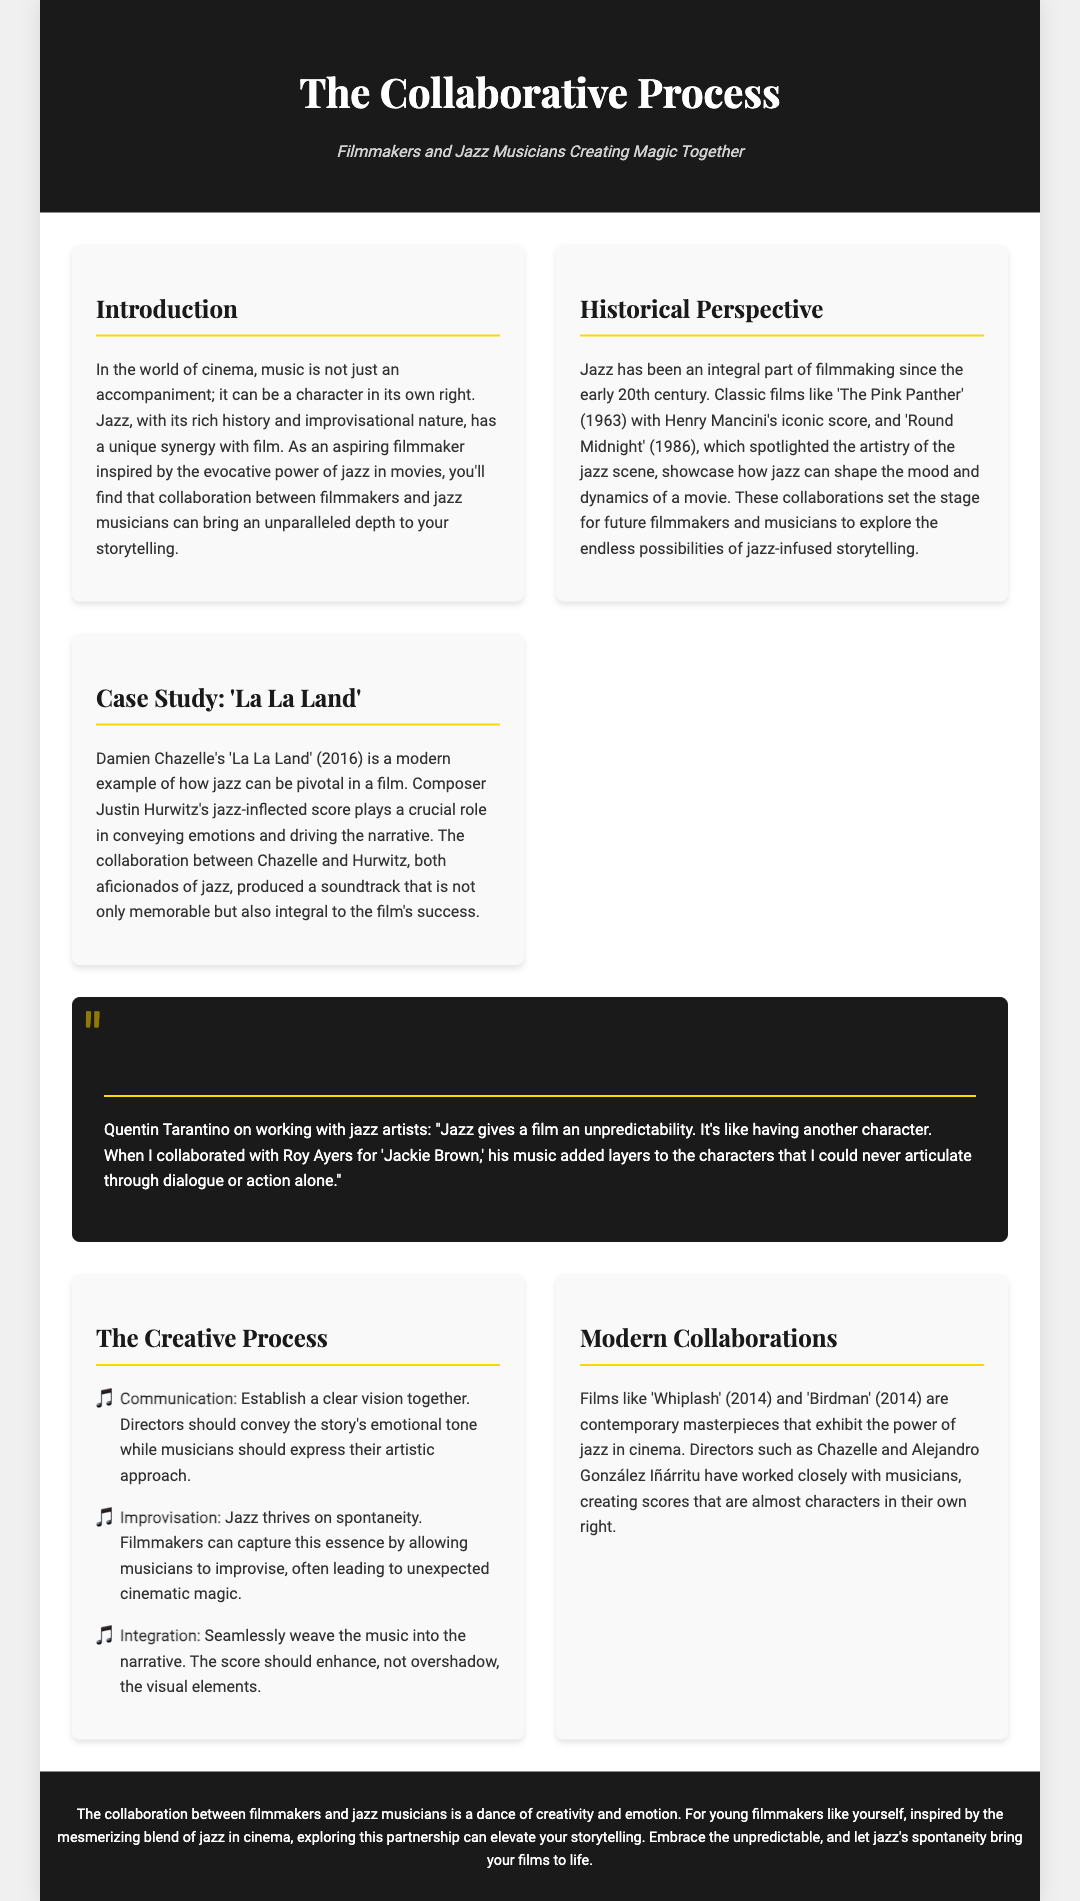what is the title of the magazine? The title of the magazine is stated in the header section of the document.
Answer: The Collaborative Process what is the subtitle of the magazine? The subtitle provides additional context about the content of the magazine.
Answer: Filmmakers and Jazz Musicians Creating Magic Together which film is mentioned as a case study? The case study highlighted in the document showcases a specific film that emphasizes jazz's role in cinema.
Answer: La La Land who composed the score for 'La La Land'? The document specifies the composer who created the jazz-inflected score for the film.
Answer: Justin Hurwitz what is the first step in the creative process? The document presents a list outlining steps in the collaborative creative process between filmmakers and jazz musicians.
Answer: Communication how does Quentin Tarantino describe jazz in film? This question addresses the quote from Tarantino about the role of jazz in filmmaking.
Answer: Unpredictability name two contemporary films mentioned that exhibit the power of jazz in cinema. The document lists films that are modern examples of jazz's influence in filmmaking.
Answer: Whiplash and Birdman which musical genre is primarily discussed in the document? The content of the magazine centers around a specific genre of music related to filmmaking.
Answer: Jazz what color is the header background? The document specifies the background color of the header section.
Answer: #1a1a1a 